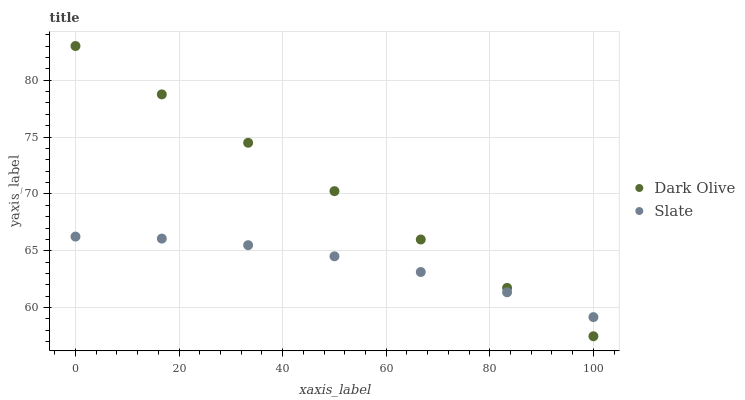Does Slate have the minimum area under the curve?
Answer yes or no. Yes. Does Dark Olive have the maximum area under the curve?
Answer yes or no. Yes. Does Dark Olive have the minimum area under the curve?
Answer yes or no. No. Is Dark Olive the smoothest?
Answer yes or no. Yes. Is Slate the roughest?
Answer yes or no. Yes. Is Dark Olive the roughest?
Answer yes or no. No. Does Dark Olive have the lowest value?
Answer yes or no. Yes. Does Dark Olive have the highest value?
Answer yes or no. Yes. Does Dark Olive intersect Slate?
Answer yes or no. Yes. Is Dark Olive less than Slate?
Answer yes or no. No. Is Dark Olive greater than Slate?
Answer yes or no. No. 